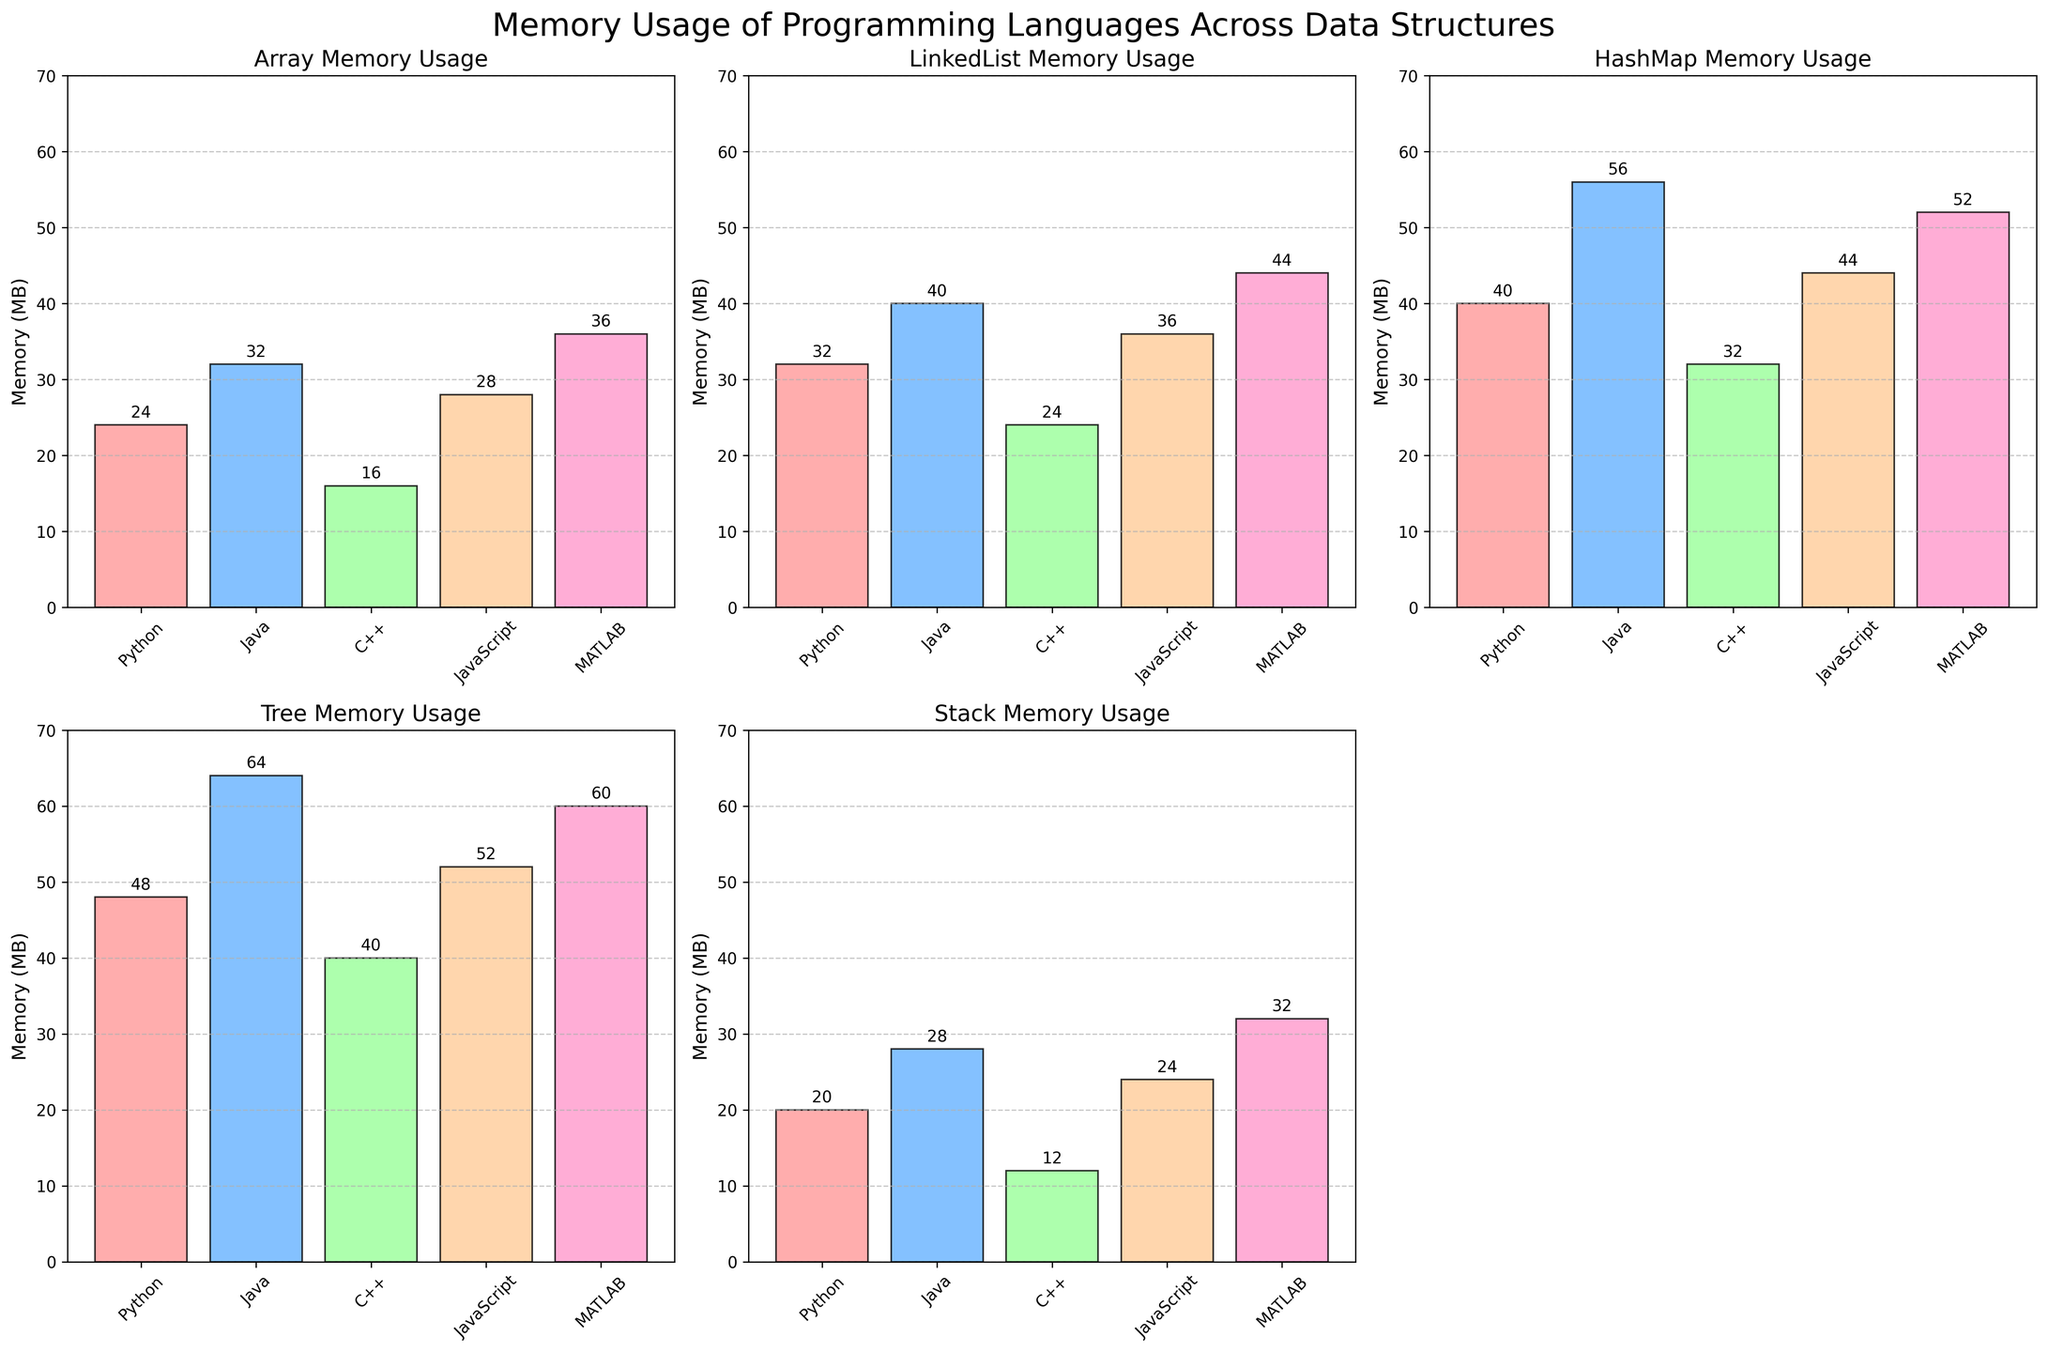What's the title of the figure? The title is at the top of the figure in a larger font size than other text. It reads 'Memory Usage of Programming Languages Across Data Structures'.
Answer: Memory Usage of Programming Languages Across Data Structures What programming language has the highest memory usage for Stacks? In the subplot for Stack Memory Usage, MATLAB has the highest bar, indicating the highest memory usage.
Answer: MATLAB Which data structure has the highest overall memory usage? By assessing the highest value in each of the subplots, Java's Tree memory usage is the highest at 64 MB, which is higher than any other individual memory usage across the other data structures.
Answer: Tree How does Python's memory usage for HashMaps compare to Java's memory usage for HashMaps? In the HashMap Memory Usage subplot, Python has a bar of 40 MB and Java has a bar of 56 MB. Java’s memory usage is clearly higher than Python’s for HashMaps.
Answer: Python's HashMap memory usage is less than Java's What's the difference between memory usage of C++ for Arrays and for LinkedLists? In the Array Memory Usage subplot, the value for C++ is 16 MB. In the LinkedList Memory Usage subplot, the value for C++ is 24 MB. The difference between these values is 24 - 16 = 8 MB.
Answer: 8 MB What is the average memory usage for JavaScript across all data structures? Summing JavaScript's memory usage values (28 for Array, 36 for LinkedList, 44 for HashMap, 52 for Tree, 24 for Stack) gives 184. Dividing by 5 gives an average of 184 / 5 = 36.8 MB.
Answer: 36.8 MB What is the minimum memory usage for MATLAB across all data structures? In each of MATLAB's subplots, the memory values are 36 (Array), 44 (LinkedList), 52 (HashMap), 60 (Tree), and 32 (Stack). The minimum value among these is 32 MB.
Answer: 32 MB How does Java's memory usage for Trees compare with MATLAB's memory usage for Trees? In the Tree Memory Usage subplot, Java has a bar at 64 MB, which is higher than MATLAB’s bar at 60 MB.
Answer: Java’s Tree memory usage is higher than MATLAB’s What is C++'s second highest memory usage, and which data structure is it for? Reviewing each value for C++ (16 for Array, 24 for LinkedList, 32 for HashMap, 40 for Tree, 12 for Stack), the second highest value is for HashMap at 32 MB.
Answer: HashMap Which language shows the most uniform memory usage across different data structures? By observing the height of the bars within each language across all subplots, MATLAB shows the least variation with values ranging from 32 to 60 MB, indicating uniform memory usage.
Answer: MATLAB 